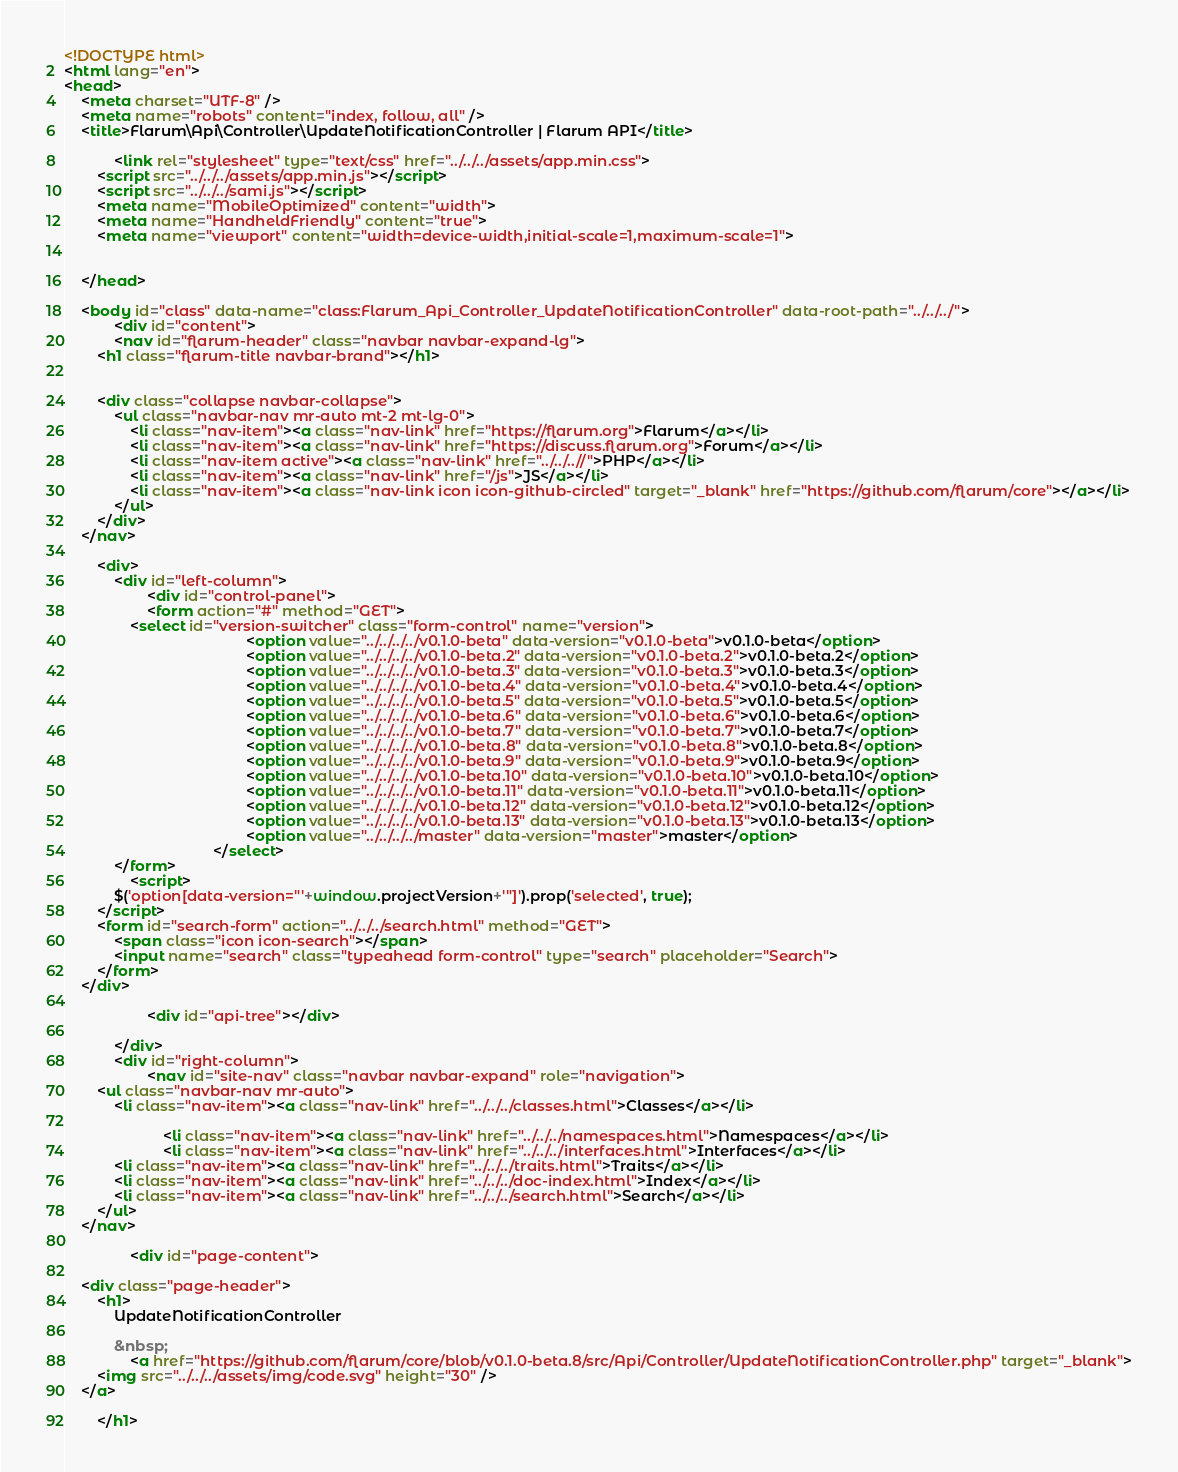Convert code to text. <code><loc_0><loc_0><loc_500><loc_500><_HTML_><!DOCTYPE html>
<html lang="en">
<head>
    <meta charset="UTF-8" />
    <meta name="robots" content="index, follow, all" />
    <title>Flarum\Api\Controller\UpdateNotificationController | Flarum API</title>

            <link rel="stylesheet" type="text/css" href="../../../assets/app.min.css">
        <script src="../../../assets/app.min.js"></script>
        <script src="../../../sami.js"></script>
        <meta name="MobileOptimized" content="width">
        <meta name="HandheldFriendly" content="true">
        <meta name="viewport" content="width=device-width,initial-scale=1,maximum-scale=1">
    
    
    </head>

    <body id="class" data-name="class:Flarum_Api_Controller_UpdateNotificationController" data-root-path="../../../">
            <div id="content">
            <nav id="flarum-header" class="navbar navbar-expand-lg">
        <h1 class="flarum-title navbar-brand"></h1>

        
        <div class="collapse navbar-collapse">
            <ul class="navbar-nav mr-auto mt-2 mt-lg-0">
                <li class="nav-item"><a class="nav-link" href="https://flarum.org">Flarum</a></li>
                <li class="nav-item"><a class="nav-link" href="https://discuss.flarum.org">Forum</a></li>
                <li class="nav-item active"><a class="nav-link" href="../../..//">PHP</a></li>
                <li class="nav-item"><a class="nav-link" href="/js">JS</a></li>
                <li class="nav-item"><a class="nav-link icon icon-github-circled" target="_blank" href="https://github.com/flarum/core"></a></li>
            </ul>
        </div>
    </nav>

        <div>
            <div id="left-column">
                    <div id="control-panel">
                    <form action="#" method="GET">
                <select id="version-switcher" class="form-control" name="version">
                                            <option value="../../../../v0.1.0-beta" data-version="v0.1.0-beta">v0.1.0-beta</option>
                                            <option value="../../../../v0.1.0-beta.2" data-version="v0.1.0-beta.2">v0.1.0-beta.2</option>
                                            <option value="../../../../v0.1.0-beta.3" data-version="v0.1.0-beta.3">v0.1.0-beta.3</option>
                                            <option value="../../../../v0.1.0-beta.4" data-version="v0.1.0-beta.4">v0.1.0-beta.4</option>
                                            <option value="../../../../v0.1.0-beta.5" data-version="v0.1.0-beta.5">v0.1.0-beta.5</option>
                                            <option value="../../../../v0.1.0-beta.6" data-version="v0.1.0-beta.6">v0.1.0-beta.6</option>
                                            <option value="../../../../v0.1.0-beta.7" data-version="v0.1.0-beta.7">v0.1.0-beta.7</option>
                                            <option value="../../../../v0.1.0-beta.8" data-version="v0.1.0-beta.8">v0.1.0-beta.8</option>
                                            <option value="../../../../v0.1.0-beta.9" data-version="v0.1.0-beta.9">v0.1.0-beta.9</option>
                                            <option value="../../../../v0.1.0-beta.10" data-version="v0.1.0-beta.10">v0.1.0-beta.10</option>
                                            <option value="../../../../v0.1.0-beta.11" data-version="v0.1.0-beta.11">v0.1.0-beta.11</option>
                                            <option value="../../../../v0.1.0-beta.12" data-version="v0.1.0-beta.12">v0.1.0-beta.12</option>
                                            <option value="../../../../v0.1.0-beta.13" data-version="v0.1.0-beta.13">v0.1.0-beta.13</option>
                                            <option value="../../../../master" data-version="master">master</option>
                                    </select>
            </form>
                <script>
            $('option[data-version="'+window.projectVersion+'"]').prop('selected', true);
        </script>
        <form id="search-form" action="../../../search.html" method="GET">
            <span class="icon icon-search"></span>
            <input name="search" class="typeahead form-control" type="search" placeholder="Search">
        </form>
    </div>

                    <div id="api-tree"></div>

            </div>
            <div id="right-column">
                    <nav id="site-nav" class="navbar navbar-expand" role="navigation">
        <ul class="navbar-nav mr-auto">
            <li class="nav-item"><a class="nav-link" href="../../../classes.html">Classes</a></li>

                        <li class="nav-item"><a class="nav-link" href="../../../namespaces.html">Namespaces</a></li>
                        <li class="nav-item"><a class="nav-link" href="../../../interfaces.html">Interfaces</a></li>
            <li class="nav-item"><a class="nav-link" href="../../../traits.html">Traits</a></li>
            <li class="nav-item"><a class="nav-link" href="../../../doc-index.html">Index</a></li>
            <li class="nav-item"><a class="nav-link" href="../../../search.html">Search</a></li>
        </ul>
    </nav>

                <div id="page-content">
                    
    <div class="page-header">
        <h1>
            UpdateNotificationController
                
            &nbsp;
                <a href="https://github.com/flarum/core/blob/v0.1.0-beta.8/src/Api/Controller/UpdateNotificationController.php" target="_blank">
        <img src="../../../assets/img/code.svg" height="30" />
    </a>

        </h1></code> 